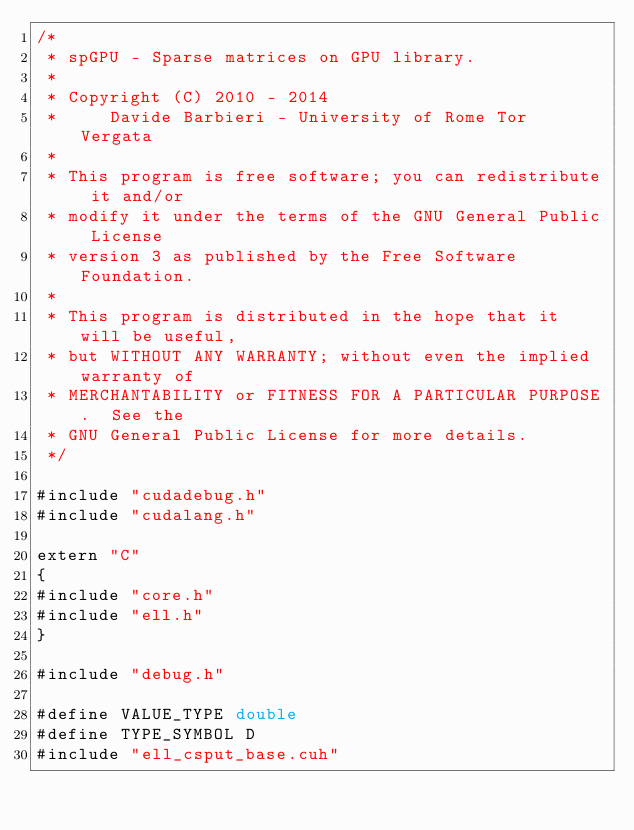Convert code to text. <code><loc_0><loc_0><loc_500><loc_500><_Cuda_>/*
 * spGPU - Sparse matrices on GPU library.
 * 
 * Copyright (C) 2010 - 2014
 *     Davide Barbieri - University of Rome Tor Vergata
 *
 * This program is free software; you can redistribute it and/or
 * modify it under the terms of the GNU General Public License
 * version 3 as published by the Free Software Foundation.
 *
 * This program is distributed in the hope that it will be useful,
 * but WITHOUT ANY WARRANTY; without even the implied warranty of
 * MERCHANTABILITY or FITNESS FOR A PARTICULAR PURPOSE.  See the
 * GNU General Public License for more details.
 */

#include "cudadebug.h"
#include "cudalang.h"

extern "C"
{
#include "core.h"
#include "ell.h"
}

#include "debug.h"

#define VALUE_TYPE double
#define TYPE_SYMBOL D
#include "ell_csput_base.cuh"

</code> 